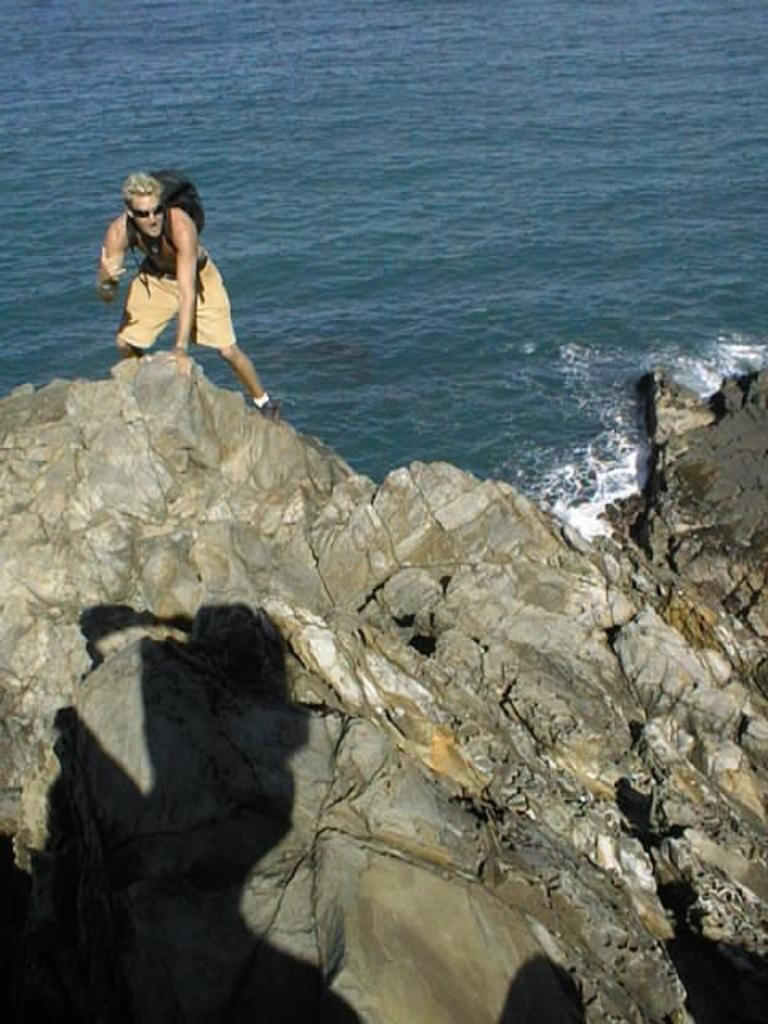What is the person in the image doing? The person is standing on a rock in the image. What can be seen in the background of the image? There is water visible in the image. What type of cup is the person holding in the image? There is no cup present in the image; the person is standing on a rock with no visible objects in their hands. 